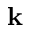<formula> <loc_0><loc_0><loc_500><loc_500>{ k }</formula> 